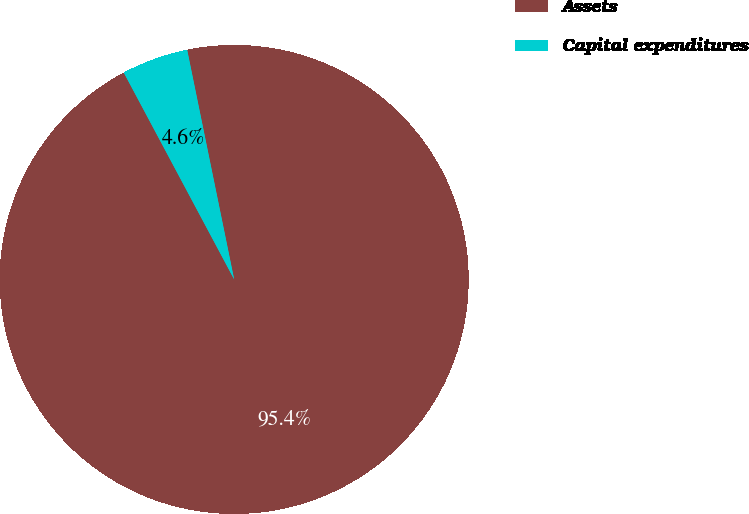<chart> <loc_0><loc_0><loc_500><loc_500><pie_chart><fcel>Assets<fcel>Capital expenditures<nl><fcel>95.41%<fcel>4.59%<nl></chart> 